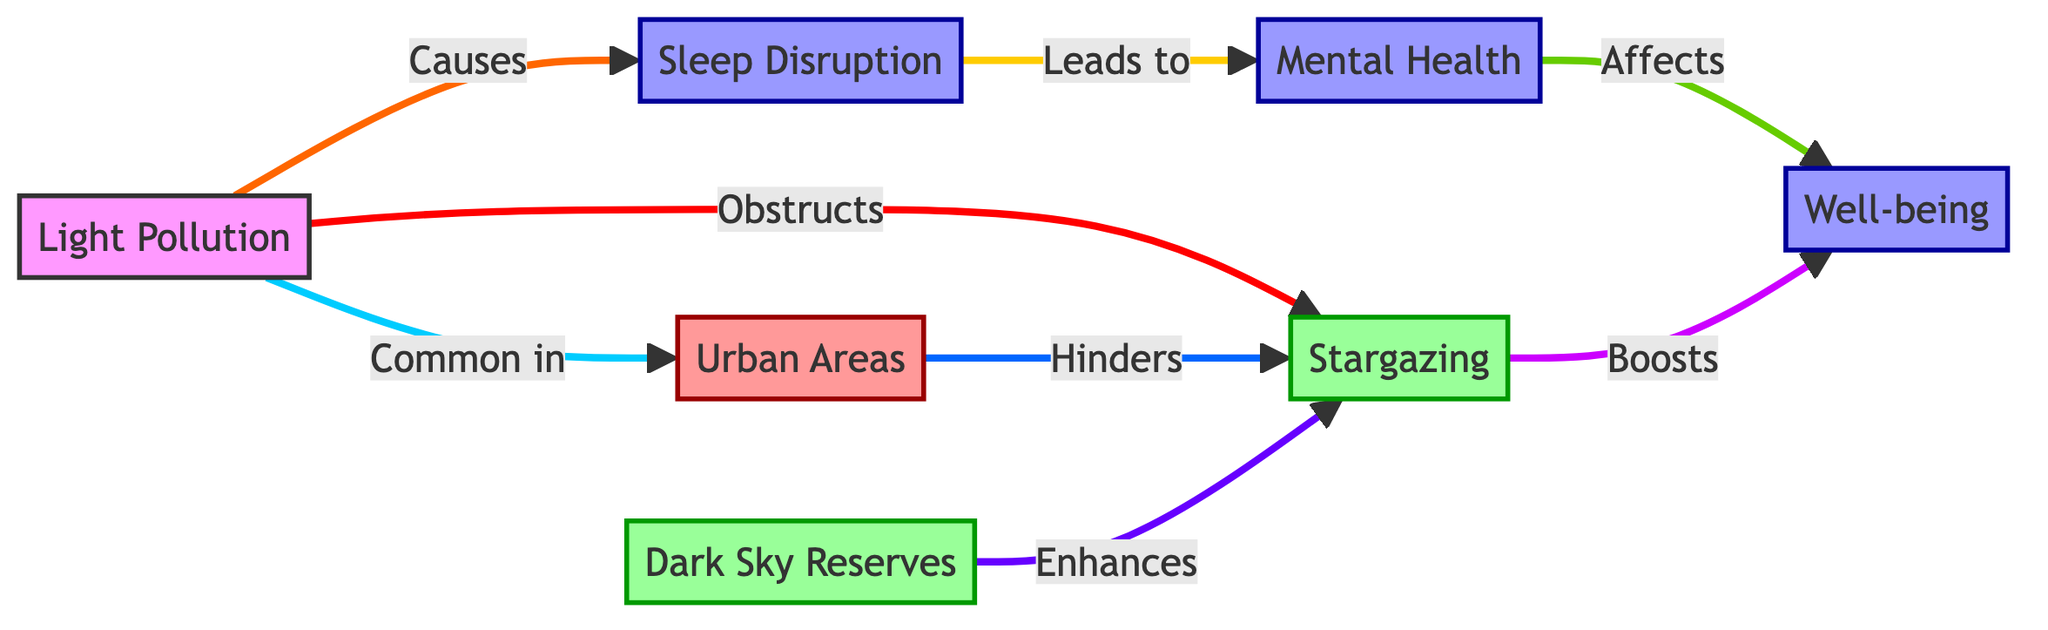What is the main factor that obstructs stargazing? The diagram shows that Light Pollution is the main factor that directly obstructs stargazing. It's indicated by the arrow from the Light Pollution node to the Stargazing node.
Answer: Light Pollution Which type of areas commonly experience light pollution? According to the diagram, Urban Areas are specified as the areas where light pollution is common, as indicated by the connection from Light Pollution to Urban Areas.
Answer: Urban Areas How does sleep disruption affect mental health? The flow from Sleep Disruption to Mental Health indicates a direct causal relationship, meaning that sleep disruption leads to issues with mental health. This can be inferred by following the arrows in the sequence.
Answer: Leads to What enhances stargazing in the diagram? The diagram indicates that Dark Sky Reserves enhance stargazing, as shown by the arrow from Dark Sky Reserves to Stargazing.
Answer: Dark Sky Reserves What is the effect of stargazing on well-being? The arrow points from Stargazing to Well-being, indicating that stargazing has a positive effect on well-being, thereby enhancing it.
Answer: Boosts How many total nodes are present in the diagram? Counting the distinct nodes presents Light Pollution, Stargazing, Well-being, Sleep Disruption, Mental Health, Urban Areas, and Dark Sky Reserves, there are a total of 7 nodes in the diagram.
Answer: 7 